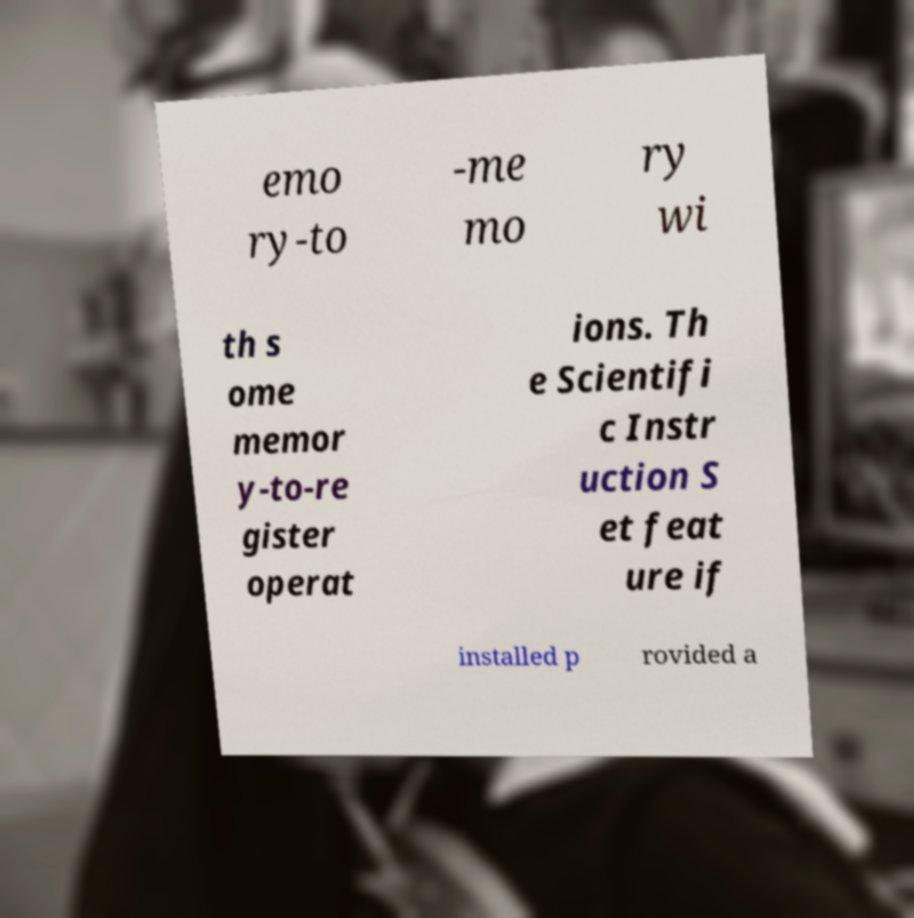There's text embedded in this image that I need extracted. Can you transcribe it verbatim? emo ry-to -me mo ry wi th s ome memor y-to-re gister operat ions. Th e Scientifi c Instr uction S et feat ure if installed p rovided a 